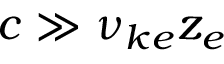Convert formula to latex. <formula><loc_0><loc_0><loc_500><loc_500>c \gg \nu _ { k e } z _ { e }</formula> 